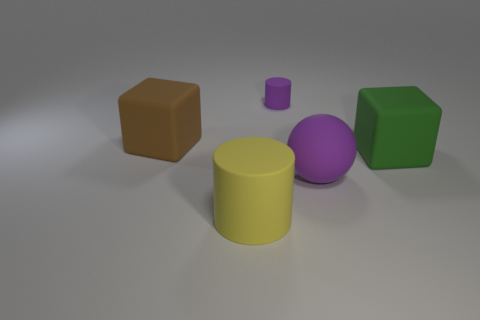Add 2 tiny cyan rubber balls. How many objects exist? 7 Subtract all purple cylinders. How many cylinders are left? 1 Subtract all balls. How many objects are left? 4 Subtract 1 blocks. How many blocks are left? 1 Subtract all gray cubes. Subtract all purple cylinders. How many cubes are left? 2 Subtract all purple matte cylinders. Subtract all tiny yellow blocks. How many objects are left? 4 Add 4 rubber cubes. How many rubber cubes are left? 6 Add 1 tiny green rubber cubes. How many tiny green rubber cubes exist? 1 Subtract 0 yellow cubes. How many objects are left? 5 